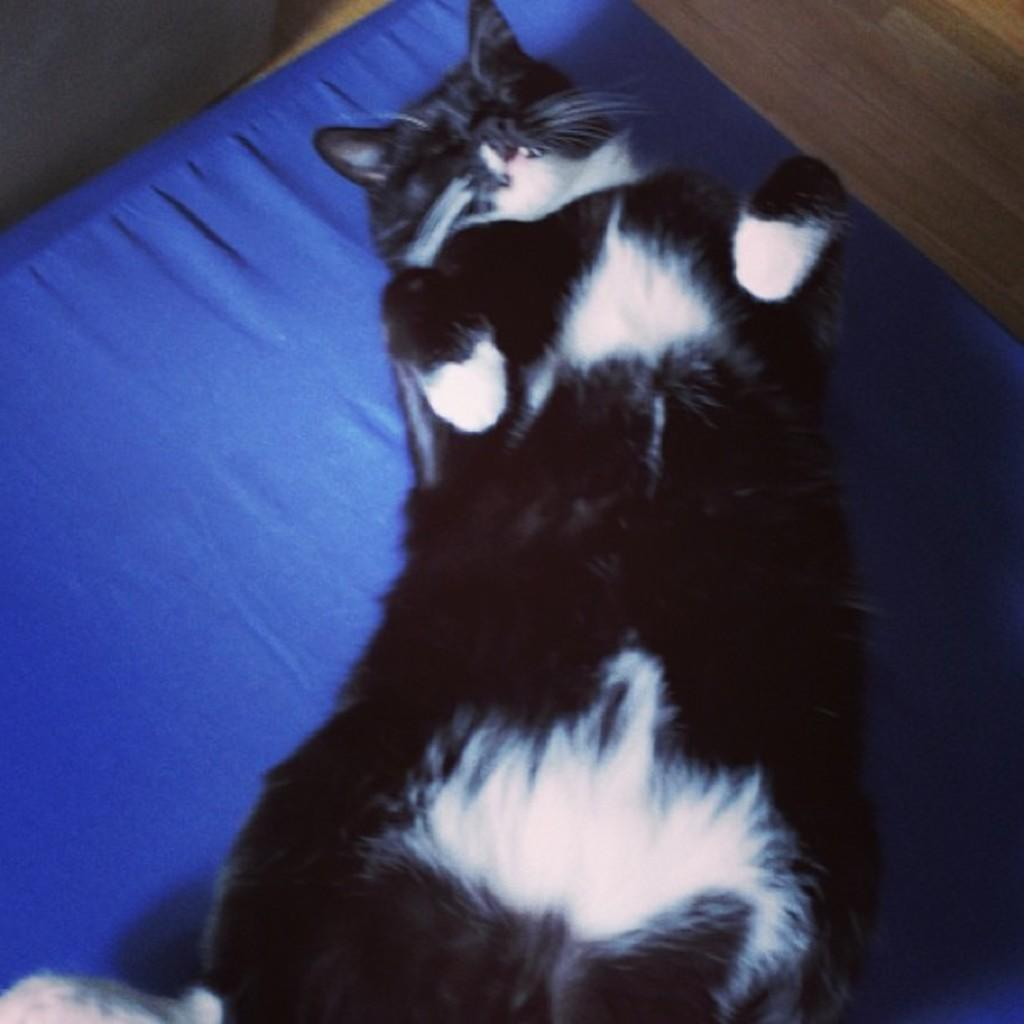What animal can be seen in the image? There is a cat in the image. What is the cat doing in the image? The cat is laying on a mat. What type of surface is visible beneath the cat? There is a floor visible in the image. What type of eggs can be seen in the image? There are no eggs present in the image; it features a cat laying on a mat. What is the opinion of the cat about the current political climate? The image does not provide any information about the cat's opinion on the political climate, as it only shows the cat laying on a mat. 